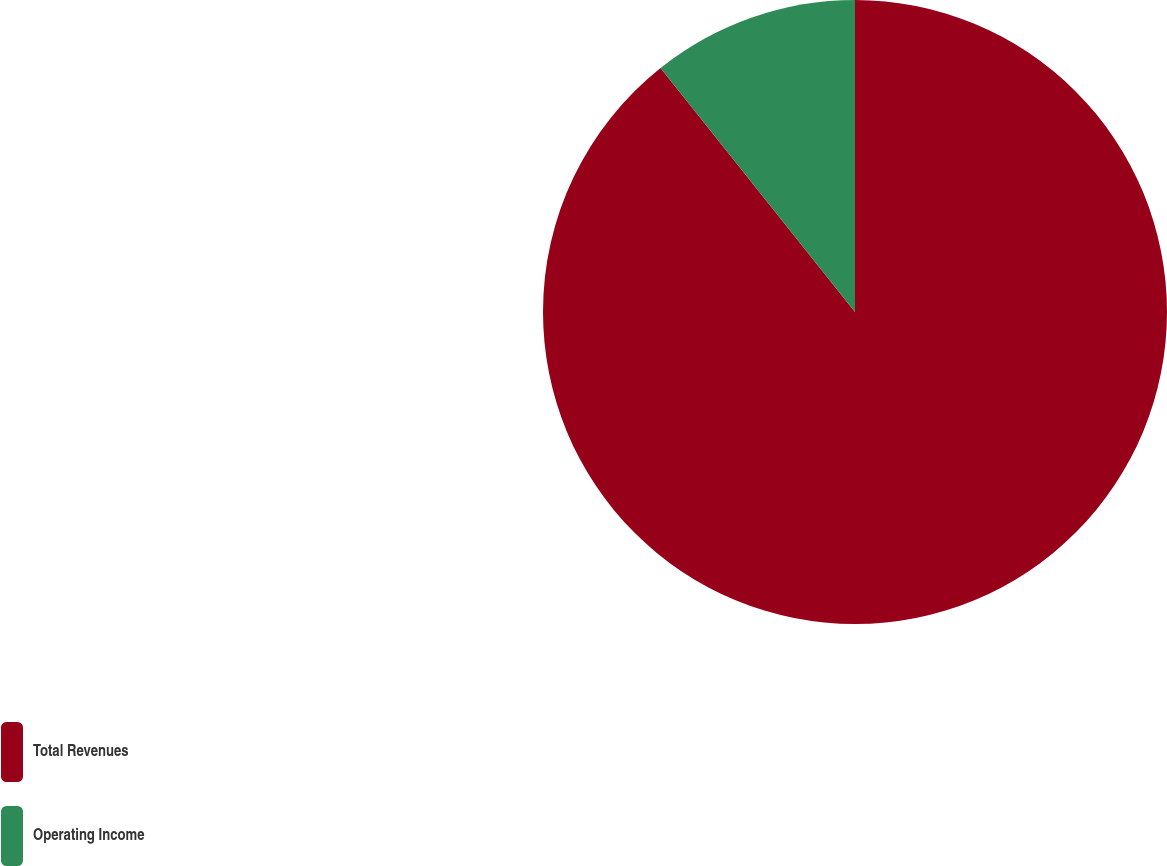Convert chart to OTSL. <chart><loc_0><loc_0><loc_500><loc_500><pie_chart><fcel>Total Revenues<fcel>Operating Income<nl><fcel>89.29%<fcel>10.71%<nl></chart> 